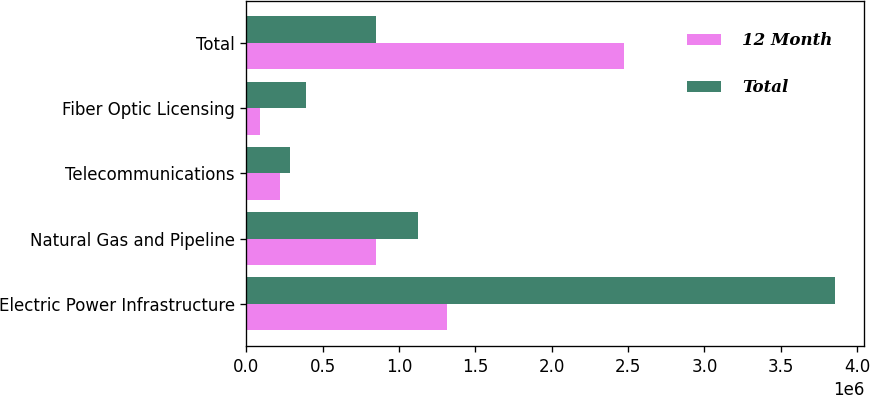Convert chart. <chart><loc_0><loc_0><loc_500><loc_500><stacked_bar_chart><ecel><fcel>Electric Power Infrastructure<fcel>Natural Gas and Pipeline<fcel>Telecommunications<fcel>Fiber Optic Licensing<fcel>Total<nl><fcel>12 Month<fcel>1.31214e+06<fcel>847702<fcel>222999<fcel>87786<fcel>2.47063e+06<nl><fcel>Total<fcel>3.85532e+06<fcel>1.1208e+06<fcel>285295<fcel>387373<fcel>847702<nl></chart> 